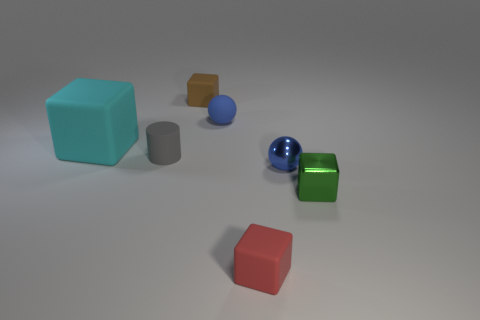How many blue balls must be subtracted to get 1 blue balls? 1 Subtract all matte cubes. How many cubes are left? 1 Subtract all red cubes. How many cubes are left? 3 Subtract 1 blocks. How many blocks are left? 3 Add 3 tiny cyan metallic blocks. How many objects exist? 10 Subtract all purple blocks. Subtract all blue cylinders. How many blocks are left? 4 Subtract all blocks. How many objects are left? 3 Subtract 0 brown cylinders. How many objects are left? 7 Subtract all tiny metal balls. Subtract all big gray matte cylinders. How many objects are left? 6 Add 2 metal things. How many metal things are left? 4 